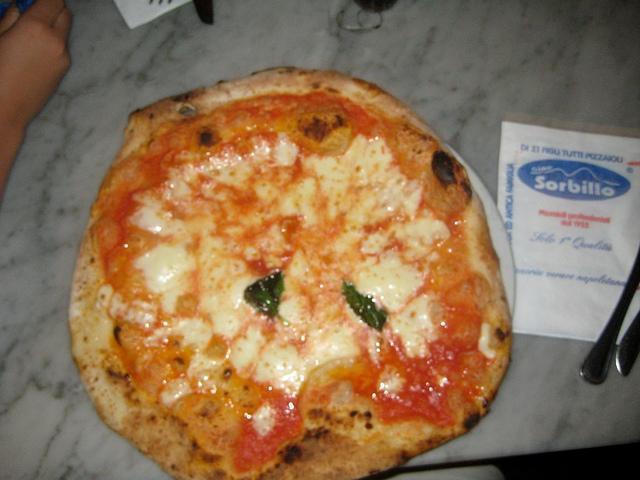How many people are wearing a tie in the picture?
Give a very brief answer. 0. 